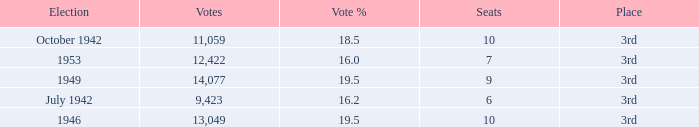Name the sum of votes % more than 19.5 None. Write the full table. {'header': ['Election', 'Votes', 'Vote %', 'Seats', 'Place'], 'rows': [['October 1942', '11,059', '18.5', '10', '3rd'], ['1953', '12,422', '16.0', '7', '3rd'], ['1949', '14,077', '19.5', '9', '3rd'], ['July 1942', '9,423', '16.2', '6', '3rd'], ['1946', '13,049', '19.5', '10', '3rd']]} 